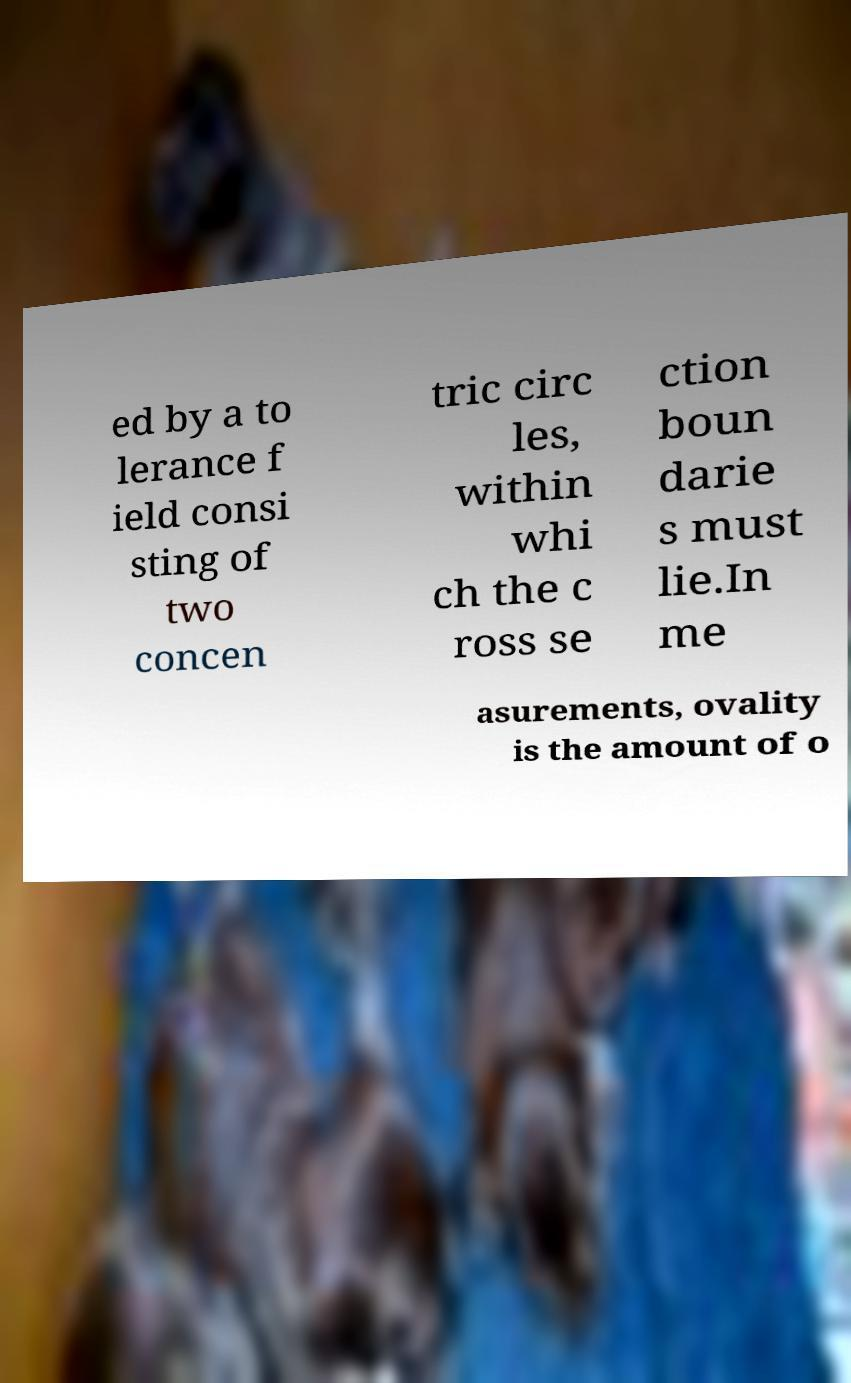Please identify and transcribe the text found in this image. ed by a to lerance f ield consi sting of two concen tric circ les, within whi ch the c ross se ction boun darie s must lie.In me asurements, ovality is the amount of o 